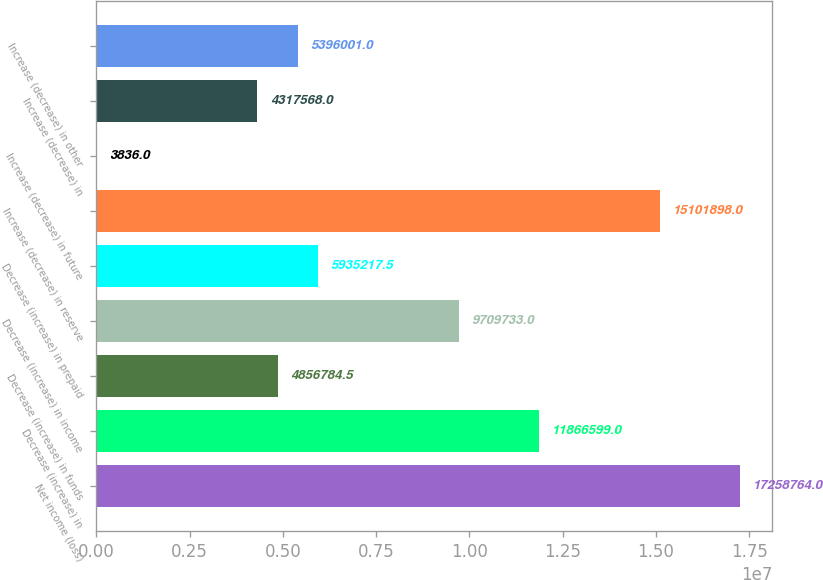<chart> <loc_0><loc_0><loc_500><loc_500><bar_chart><fcel>Net income (loss)<fcel>Decrease (increase) in<fcel>Decrease (increase) in funds<fcel>Decrease (increase) in income<fcel>Decrease (increase) in prepaid<fcel>Increase (decrease) in reserve<fcel>Increase (decrease) in future<fcel>Increase (decrease) in<fcel>Increase (decrease) in other<nl><fcel>1.72588e+07<fcel>1.18666e+07<fcel>4.85678e+06<fcel>9.70973e+06<fcel>5.93522e+06<fcel>1.51019e+07<fcel>3836<fcel>4.31757e+06<fcel>5.396e+06<nl></chart> 